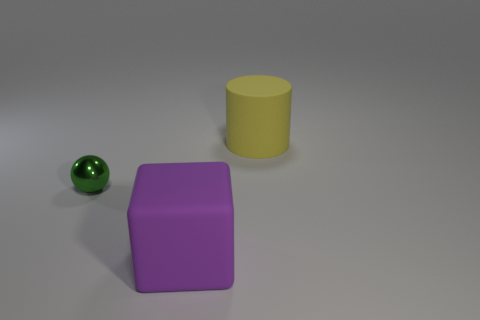Do the purple thing and the green metal thing have the same shape?
Provide a succinct answer. No. How many big purple rubber objects have the same shape as the small metallic object?
Your response must be concise. 0. There is a big purple rubber cube; what number of big purple blocks are to the left of it?
Provide a succinct answer. 0. There is a matte thing that is behind the small metallic sphere; does it have the same color as the tiny thing?
Make the answer very short. No. What number of purple rubber objects are the same size as the metallic object?
Your answer should be compact. 0. There is a purple thing that is the same material as the large yellow thing; what is its shape?
Make the answer very short. Cube. Are there any big matte blocks that have the same color as the tiny metallic object?
Provide a short and direct response. No. What is the material of the green thing?
Give a very brief answer. Metal. What number of objects are either big brown metal things or cubes?
Ensure brevity in your answer.  1. There is a thing that is in front of the tiny metallic sphere; how big is it?
Your answer should be compact. Large. 